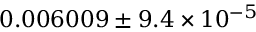Convert formula to latex. <formula><loc_0><loc_0><loc_500><loc_500>0 . 0 0 6 0 0 9 \pm 9 . 4 \times 1 0 ^ { - 5 }</formula> 